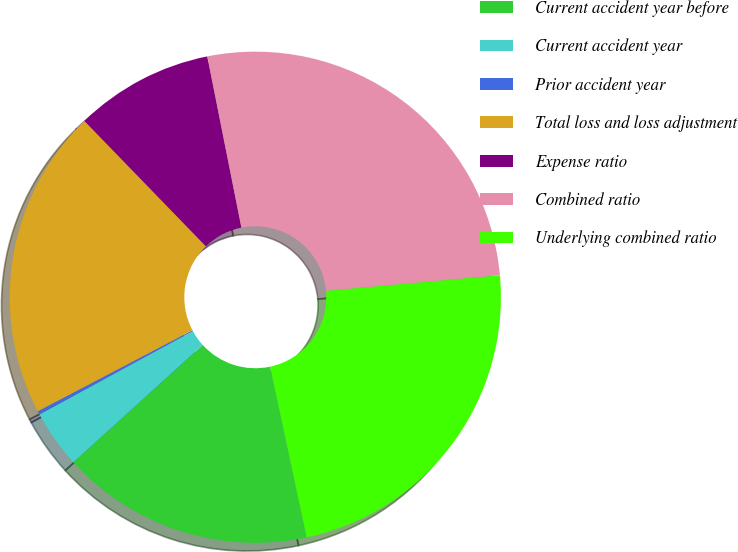<chart> <loc_0><loc_0><loc_500><loc_500><pie_chart><fcel>Current accident year before<fcel>Current accident year<fcel>Prior accident year<fcel>Total loss and loss adjustment<fcel>Expense ratio<fcel>Combined ratio<fcel>Underlying combined ratio<nl><fcel>16.63%<fcel>3.82%<fcel>0.23%<fcel>20.43%<fcel>9.12%<fcel>26.71%<fcel>23.07%<nl></chart> 